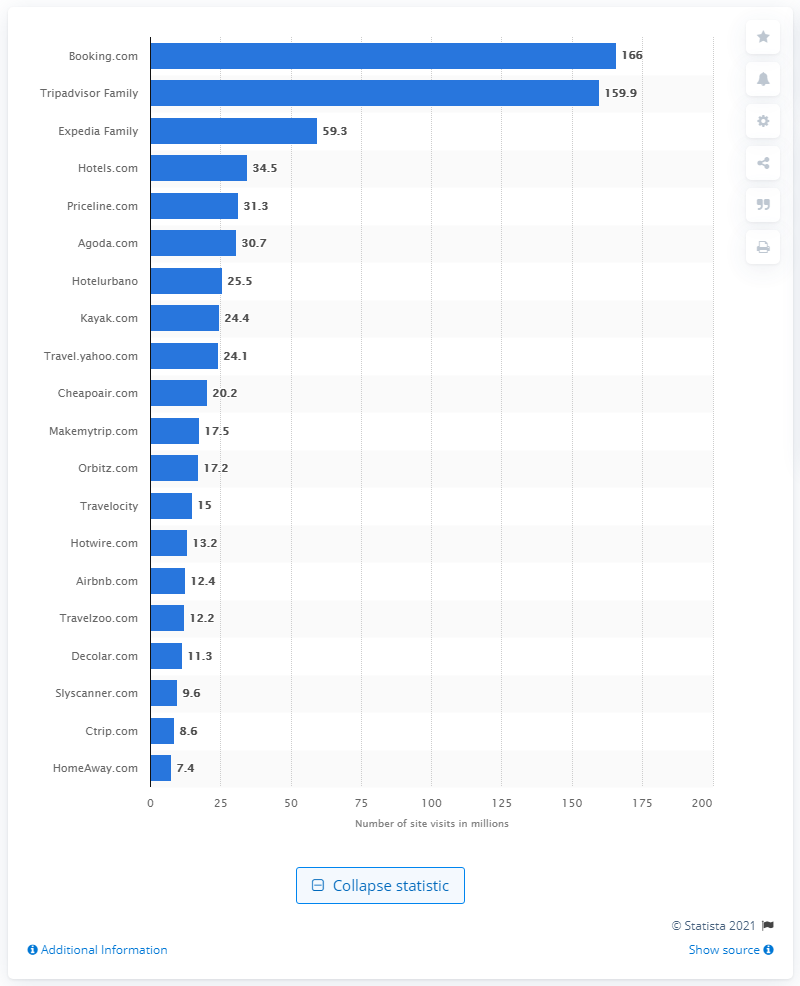Mention a couple of crucial points in this snapshot. In January 2014, the travel booking site that received the most visits was Booking.com. In January 2014, the number of visitors to Booking.com was 166. 